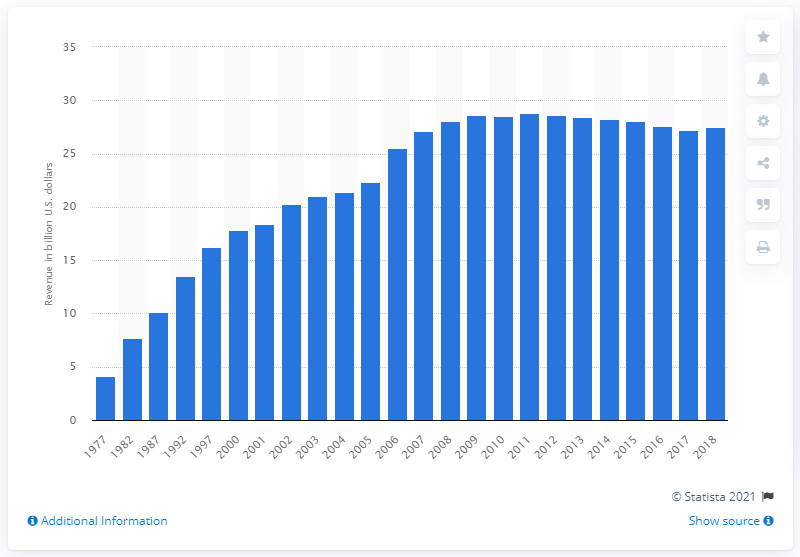Indicate a few pertinent items in this graphic. In 2018, state and local governments collected a total of $27.48 billion through public utility tax. 